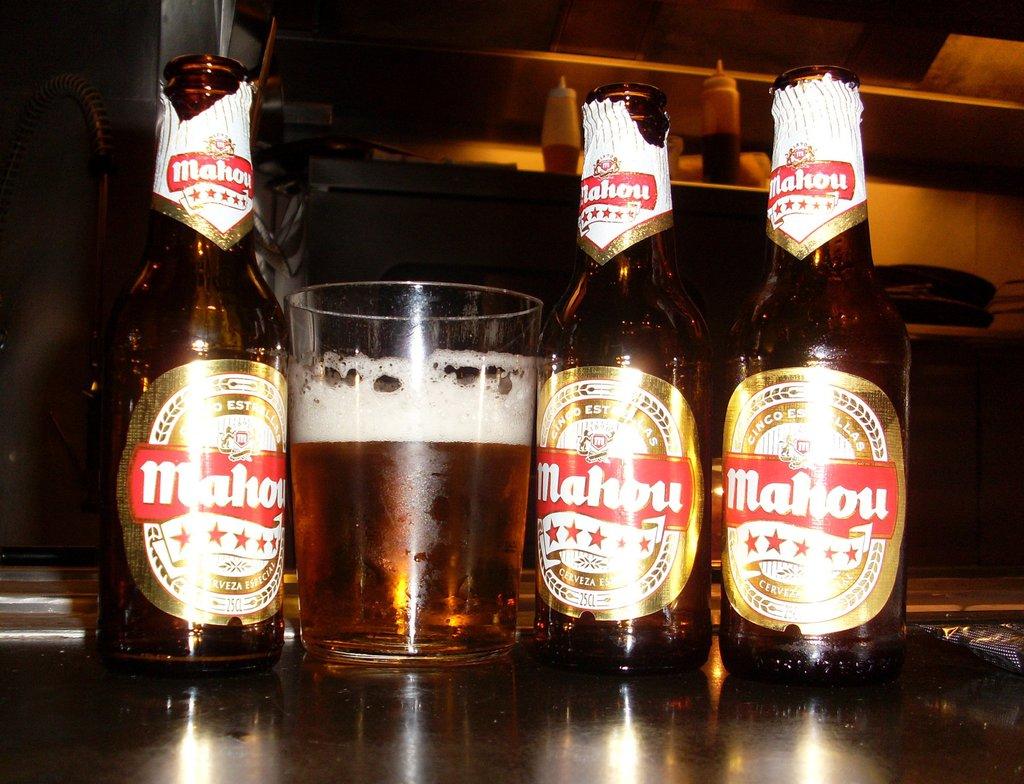How many cl in this bottle?
Keep it short and to the point. Unanswerable. 